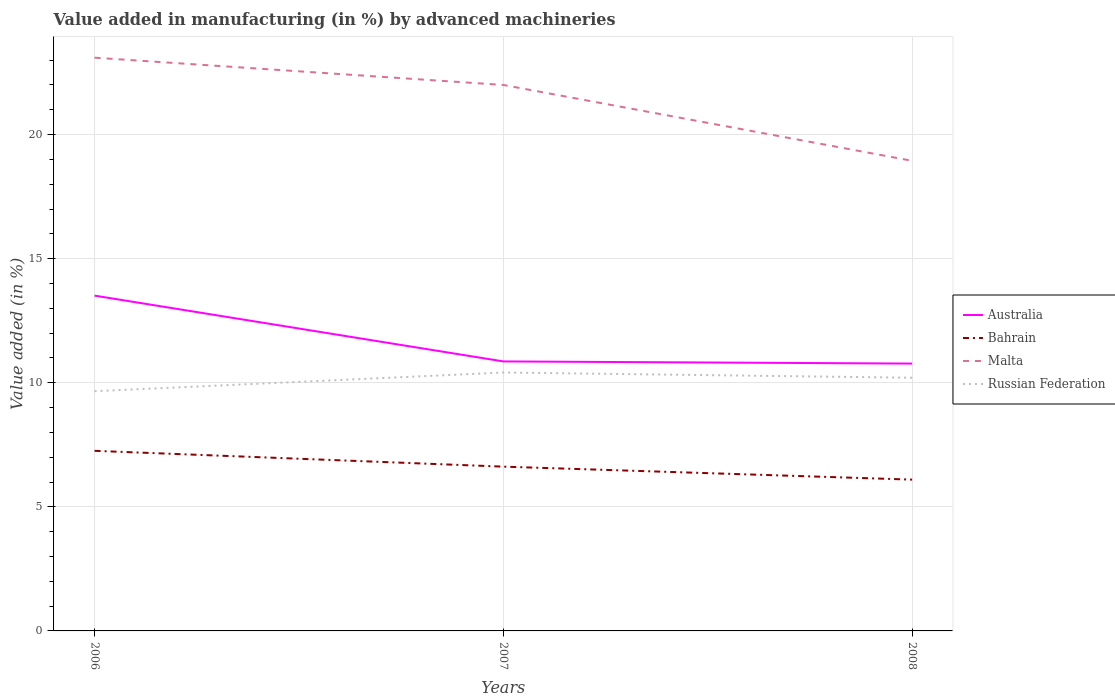Is the number of lines equal to the number of legend labels?
Provide a succinct answer. Yes. Across all years, what is the maximum percentage of value added in manufacturing by advanced machineries in Bahrain?
Your answer should be very brief. 6.1. What is the total percentage of value added in manufacturing by advanced machineries in Australia in the graph?
Provide a succinct answer. 2.65. What is the difference between the highest and the second highest percentage of value added in manufacturing by advanced machineries in Malta?
Your response must be concise. 4.16. What is the difference between the highest and the lowest percentage of value added in manufacturing by advanced machineries in Australia?
Make the answer very short. 1. How many lines are there?
Your answer should be very brief. 4. What is the difference between two consecutive major ticks on the Y-axis?
Ensure brevity in your answer.  5. How many legend labels are there?
Ensure brevity in your answer.  4. How are the legend labels stacked?
Make the answer very short. Vertical. What is the title of the graph?
Make the answer very short. Value added in manufacturing (in %) by advanced machineries. What is the label or title of the X-axis?
Keep it short and to the point. Years. What is the label or title of the Y-axis?
Your answer should be very brief. Value added (in %). What is the Value added (in %) in Australia in 2006?
Provide a succinct answer. 13.51. What is the Value added (in %) of Bahrain in 2006?
Ensure brevity in your answer.  7.26. What is the Value added (in %) in Malta in 2006?
Ensure brevity in your answer.  23.1. What is the Value added (in %) in Russian Federation in 2006?
Keep it short and to the point. 9.66. What is the Value added (in %) in Australia in 2007?
Ensure brevity in your answer.  10.86. What is the Value added (in %) of Bahrain in 2007?
Keep it short and to the point. 6.62. What is the Value added (in %) of Malta in 2007?
Make the answer very short. 22. What is the Value added (in %) in Russian Federation in 2007?
Give a very brief answer. 10.41. What is the Value added (in %) of Australia in 2008?
Your response must be concise. 10.77. What is the Value added (in %) of Bahrain in 2008?
Offer a terse response. 6.1. What is the Value added (in %) of Malta in 2008?
Make the answer very short. 18.94. What is the Value added (in %) of Russian Federation in 2008?
Provide a succinct answer. 10.2. Across all years, what is the maximum Value added (in %) in Australia?
Offer a terse response. 13.51. Across all years, what is the maximum Value added (in %) of Bahrain?
Give a very brief answer. 7.26. Across all years, what is the maximum Value added (in %) of Malta?
Keep it short and to the point. 23.1. Across all years, what is the maximum Value added (in %) in Russian Federation?
Provide a short and direct response. 10.41. Across all years, what is the minimum Value added (in %) of Australia?
Provide a short and direct response. 10.77. Across all years, what is the minimum Value added (in %) of Bahrain?
Offer a terse response. 6.1. Across all years, what is the minimum Value added (in %) of Malta?
Keep it short and to the point. 18.94. Across all years, what is the minimum Value added (in %) of Russian Federation?
Offer a terse response. 9.66. What is the total Value added (in %) in Australia in the graph?
Ensure brevity in your answer.  35.14. What is the total Value added (in %) in Bahrain in the graph?
Provide a short and direct response. 19.97. What is the total Value added (in %) in Malta in the graph?
Your answer should be compact. 64.04. What is the total Value added (in %) of Russian Federation in the graph?
Make the answer very short. 30.27. What is the difference between the Value added (in %) in Australia in 2006 and that in 2007?
Your answer should be very brief. 2.65. What is the difference between the Value added (in %) in Bahrain in 2006 and that in 2007?
Provide a succinct answer. 0.64. What is the difference between the Value added (in %) in Malta in 2006 and that in 2007?
Make the answer very short. 1.1. What is the difference between the Value added (in %) of Russian Federation in 2006 and that in 2007?
Make the answer very short. -0.75. What is the difference between the Value added (in %) in Australia in 2006 and that in 2008?
Give a very brief answer. 2.74. What is the difference between the Value added (in %) of Bahrain in 2006 and that in 2008?
Keep it short and to the point. 1.16. What is the difference between the Value added (in %) in Malta in 2006 and that in 2008?
Make the answer very short. 4.16. What is the difference between the Value added (in %) in Russian Federation in 2006 and that in 2008?
Your response must be concise. -0.54. What is the difference between the Value added (in %) in Australia in 2007 and that in 2008?
Offer a terse response. 0.09. What is the difference between the Value added (in %) in Bahrain in 2007 and that in 2008?
Ensure brevity in your answer.  0.52. What is the difference between the Value added (in %) in Malta in 2007 and that in 2008?
Your answer should be very brief. 3.06. What is the difference between the Value added (in %) in Russian Federation in 2007 and that in 2008?
Keep it short and to the point. 0.21. What is the difference between the Value added (in %) in Australia in 2006 and the Value added (in %) in Bahrain in 2007?
Your answer should be compact. 6.89. What is the difference between the Value added (in %) in Australia in 2006 and the Value added (in %) in Malta in 2007?
Your answer should be very brief. -8.49. What is the difference between the Value added (in %) in Australia in 2006 and the Value added (in %) in Russian Federation in 2007?
Keep it short and to the point. 3.1. What is the difference between the Value added (in %) of Bahrain in 2006 and the Value added (in %) of Malta in 2007?
Provide a succinct answer. -14.74. What is the difference between the Value added (in %) of Bahrain in 2006 and the Value added (in %) of Russian Federation in 2007?
Provide a short and direct response. -3.16. What is the difference between the Value added (in %) of Malta in 2006 and the Value added (in %) of Russian Federation in 2007?
Make the answer very short. 12.69. What is the difference between the Value added (in %) in Australia in 2006 and the Value added (in %) in Bahrain in 2008?
Make the answer very short. 7.41. What is the difference between the Value added (in %) in Australia in 2006 and the Value added (in %) in Malta in 2008?
Provide a succinct answer. -5.43. What is the difference between the Value added (in %) of Australia in 2006 and the Value added (in %) of Russian Federation in 2008?
Offer a very short reply. 3.31. What is the difference between the Value added (in %) in Bahrain in 2006 and the Value added (in %) in Malta in 2008?
Your answer should be compact. -11.69. What is the difference between the Value added (in %) in Bahrain in 2006 and the Value added (in %) in Russian Federation in 2008?
Offer a very short reply. -2.94. What is the difference between the Value added (in %) of Malta in 2006 and the Value added (in %) of Russian Federation in 2008?
Offer a terse response. 12.9. What is the difference between the Value added (in %) in Australia in 2007 and the Value added (in %) in Bahrain in 2008?
Ensure brevity in your answer.  4.76. What is the difference between the Value added (in %) of Australia in 2007 and the Value added (in %) of Malta in 2008?
Offer a very short reply. -8.08. What is the difference between the Value added (in %) in Australia in 2007 and the Value added (in %) in Russian Federation in 2008?
Offer a terse response. 0.66. What is the difference between the Value added (in %) of Bahrain in 2007 and the Value added (in %) of Malta in 2008?
Provide a succinct answer. -12.32. What is the difference between the Value added (in %) in Bahrain in 2007 and the Value added (in %) in Russian Federation in 2008?
Offer a terse response. -3.58. What is the difference between the Value added (in %) in Malta in 2007 and the Value added (in %) in Russian Federation in 2008?
Make the answer very short. 11.8. What is the average Value added (in %) of Australia per year?
Keep it short and to the point. 11.71. What is the average Value added (in %) of Bahrain per year?
Offer a very short reply. 6.66. What is the average Value added (in %) of Malta per year?
Make the answer very short. 21.35. What is the average Value added (in %) of Russian Federation per year?
Give a very brief answer. 10.09. In the year 2006, what is the difference between the Value added (in %) of Australia and Value added (in %) of Bahrain?
Offer a very short reply. 6.25. In the year 2006, what is the difference between the Value added (in %) in Australia and Value added (in %) in Malta?
Your response must be concise. -9.59. In the year 2006, what is the difference between the Value added (in %) of Australia and Value added (in %) of Russian Federation?
Offer a very short reply. 3.85. In the year 2006, what is the difference between the Value added (in %) in Bahrain and Value added (in %) in Malta?
Your response must be concise. -15.84. In the year 2006, what is the difference between the Value added (in %) in Bahrain and Value added (in %) in Russian Federation?
Offer a terse response. -2.4. In the year 2006, what is the difference between the Value added (in %) in Malta and Value added (in %) in Russian Federation?
Offer a terse response. 13.44. In the year 2007, what is the difference between the Value added (in %) of Australia and Value added (in %) of Bahrain?
Your answer should be very brief. 4.24. In the year 2007, what is the difference between the Value added (in %) of Australia and Value added (in %) of Malta?
Offer a terse response. -11.14. In the year 2007, what is the difference between the Value added (in %) in Australia and Value added (in %) in Russian Federation?
Your answer should be compact. 0.45. In the year 2007, what is the difference between the Value added (in %) in Bahrain and Value added (in %) in Malta?
Your answer should be compact. -15.38. In the year 2007, what is the difference between the Value added (in %) in Bahrain and Value added (in %) in Russian Federation?
Keep it short and to the point. -3.79. In the year 2007, what is the difference between the Value added (in %) of Malta and Value added (in %) of Russian Federation?
Your answer should be very brief. 11.59. In the year 2008, what is the difference between the Value added (in %) in Australia and Value added (in %) in Bahrain?
Offer a very short reply. 4.68. In the year 2008, what is the difference between the Value added (in %) in Australia and Value added (in %) in Malta?
Your answer should be very brief. -8.17. In the year 2008, what is the difference between the Value added (in %) in Australia and Value added (in %) in Russian Federation?
Your response must be concise. 0.57. In the year 2008, what is the difference between the Value added (in %) in Bahrain and Value added (in %) in Malta?
Your answer should be compact. -12.85. In the year 2008, what is the difference between the Value added (in %) in Bahrain and Value added (in %) in Russian Federation?
Your answer should be compact. -4.11. In the year 2008, what is the difference between the Value added (in %) of Malta and Value added (in %) of Russian Federation?
Provide a short and direct response. 8.74. What is the ratio of the Value added (in %) in Australia in 2006 to that in 2007?
Give a very brief answer. 1.24. What is the ratio of the Value added (in %) in Bahrain in 2006 to that in 2007?
Offer a very short reply. 1.1. What is the ratio of the Value added (in %) in Malta in 2006 to that in 2007?
Give a very brief answer. 1.05. What is the ratio of the Value added (in %) of Russian Federation in 2006 to that in 2007?
Keep it short and to the point. 0.93. What is the ratio of the Value added (in %) of Australia in 2006 to that in 2008?
Your answer should be compact. 1.25. What is the ratio of the Value added (in %) of Bahrain in 2006 to that in 2008?
Offer a terse response. 1.19. What is the ratio of the Value added (in %) in Malta in 2006 to that in 2008?
Keep it short and to the point. 1.22. What is the ratio of the Value added (in %) in Russian Federation in 2006 to that in 2008?
Offer a very short reply. 0.95. What is the ratio of the Value added (in %) of Bahrain in 2007 to that in 2008?
Offer a terse response. 1.09. What is the ratio of the Value added (in %) in Malta in 2007 to that in 2008?
Ensure brevity in your answer.  1.16. What is the ratio of the Value added (in %) in Russian Federation in 2007 to that in 2008?
Make the answer very short. 1.02. What is the difference between the highest and the second highest Value added (in %) of Australia?
Your response must be concise. 2.65. What is the difference between the highest and the second highest Value added (in %) of Bahrain?
Your answer should be compact. 0.64. What is the difference between the highest and the second highest Value added (in %) of Malta?
Give a very brief answer. 1.1. What is the difference between the highest and the second highest Value added (in %) of Russian Federation?
Offer a very short reply. 0.21. What is the difference between the highest and the lowest Value added (in %) of Australia?
Your response must be concise. 2.74. What is the difference between the highest and the lowest Value added (in %) of Bahrain?
Your response must be concise. 1.16. What is the difference between the highest and the lowest Value added (in %) in Malta?
Make the answer very short. 4.16. What is the difference between the highest and the lowest Value added (in %) of Russian Federation?
Offer a very short reply. 0.75. 